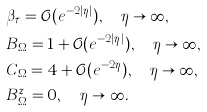<formula> <loc_0><loc_0><loc_500><loc_500>& \beta _ { \tau } = \mathcal { O } ( e ^ { - 2 | \eta | } ) , \quad \eta \to \infty , \\ & B _ { \Omega } = 1 + \mathcal { O } ( e ^ { - 2 | \eta | } ) , \quad \eta \to \infty , \\ & C _ { \Omega } = 4 + \mathcal { O } ( e ^ { - 2 \eta } ) , \quad \eta \to \infty , \\ & B ^ { z } _ { \Omega } = 0 , \quad \eta \to \infty .</formula> 